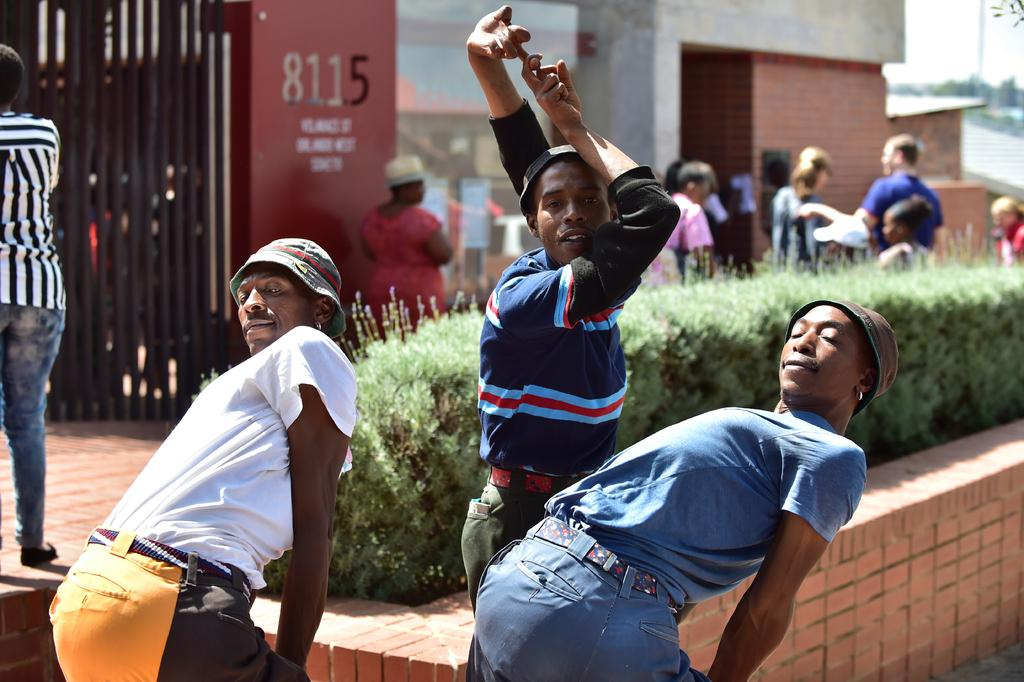What is the main subject of the image? There is a group of people standing in the image. What else can be seen in the background of the image? There are buildings and plants visible in the image. What part of the natural environment is visible in the image? The sky is visible in the top right corner of the image. What decision is the group of people making in the image? There is no indication in the image of a decision being made by the group of people. 